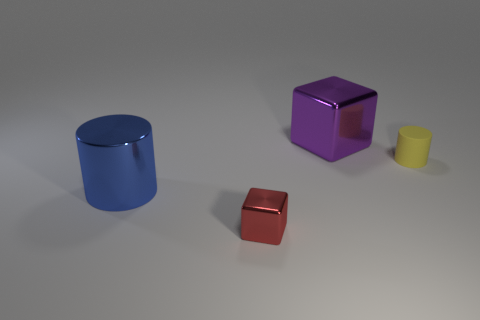What shape is the tiny thing behind the blue cylinder?
Provide a succinct answer. Cylinder. How many red objects are big cylinders or small metal objects?
Offer a terse response. 1. Does the red cube have the same material as the tiny yellow object?
Provide a short and direct response. No. There is a large blue metal object; how many small objects are behind it?
Provide a succinct answer. 1. What is the material of the object that is in front of the big purple block and on the right side of the small red block?
Your answer should be compact. Rubber. How many blocks are shiny objects or yellow things?
Keep it short and to the point. 2. What is the material of the small thing that is the same shape as the large blue thing?
Your response must be concise. Rubber. There is a red thing that is the same material as the blue thing; what is its size?
Your response must be concise. Small. Do the metallic thing that is behind the blue thing and the big object in front of the purple shiny block have the same shape?
Ensure brevity in your answer.  No. What color is the small thing that is made of the same material as the large cube?
Your answer should be compact. Red. 